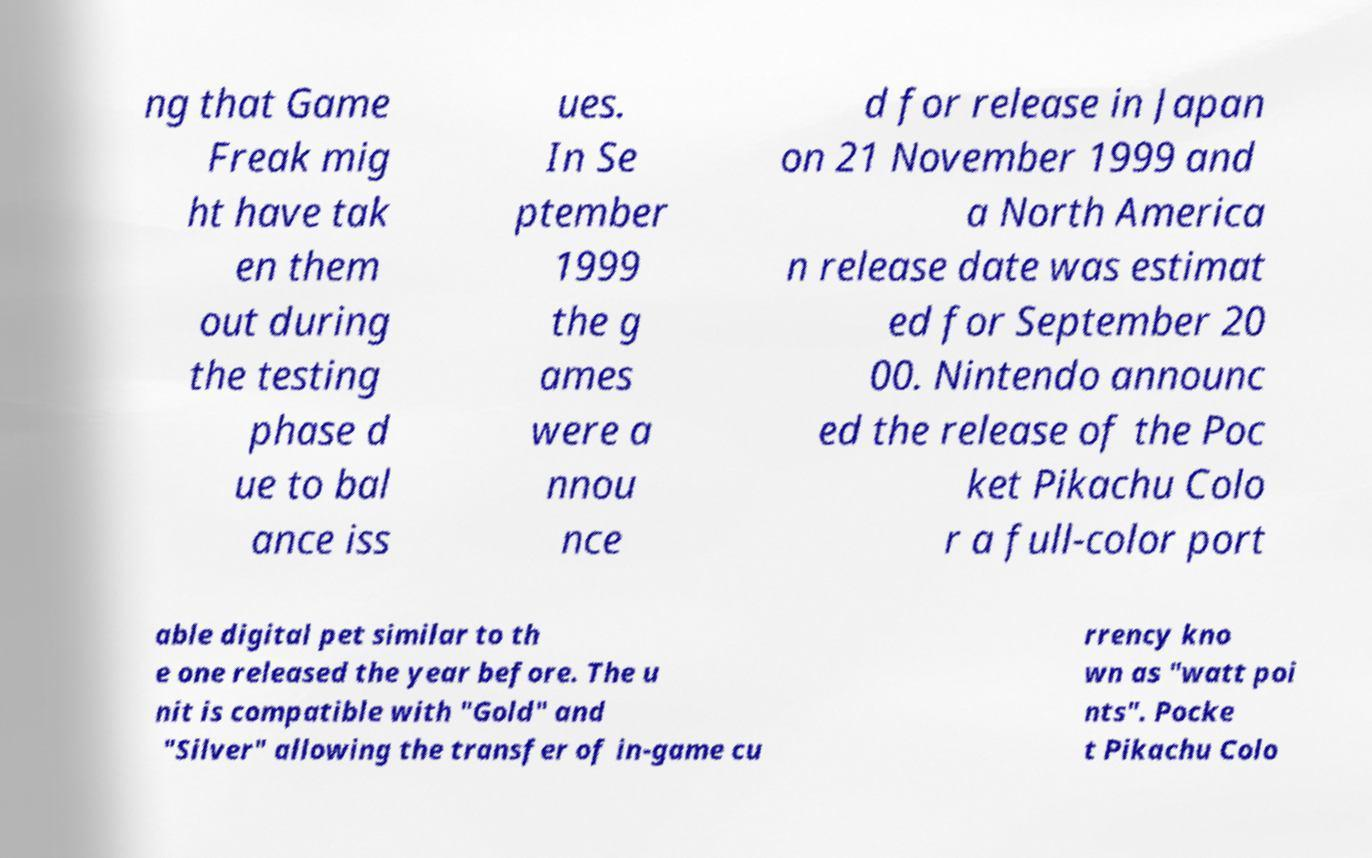Could you assist in decoding the text presented in this image and type it out clearly? ng that Game Freak mig ht have tak en them out during the testing phase d ue to bal ance iss ues. In Se ptember 1999 the g ames were a nnou nce d for release in Japan on 21 November 1999 and a North America n release date was estimat ed for September 20 00. Nintendo announc ed the release of the Poc ket Pikachu Colo r a full-color port able digital pet similar to th e one released the year before. The u nit is compatible with "Gold" and "Silver" allowing the transfer of in-game cu rrency kno wn as "watt poi nts". Pocke t Pikachu Colo 